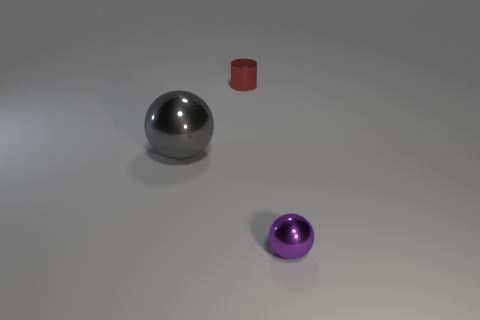Add 1 big green matte spheres. How many objects exist? 4 Subtract all spheres. How many objects are left? 1 Subtract 0 green blocks. How many objects are left? 3 Subtract all big gray shiny things. Subtract all small metallic spheres. How many objects are left? 1 Add 1 red shiny objects. How many red shiny objects are left? 2 Add 1 gray metallic objects. How many gray metallic objects exist? 2 